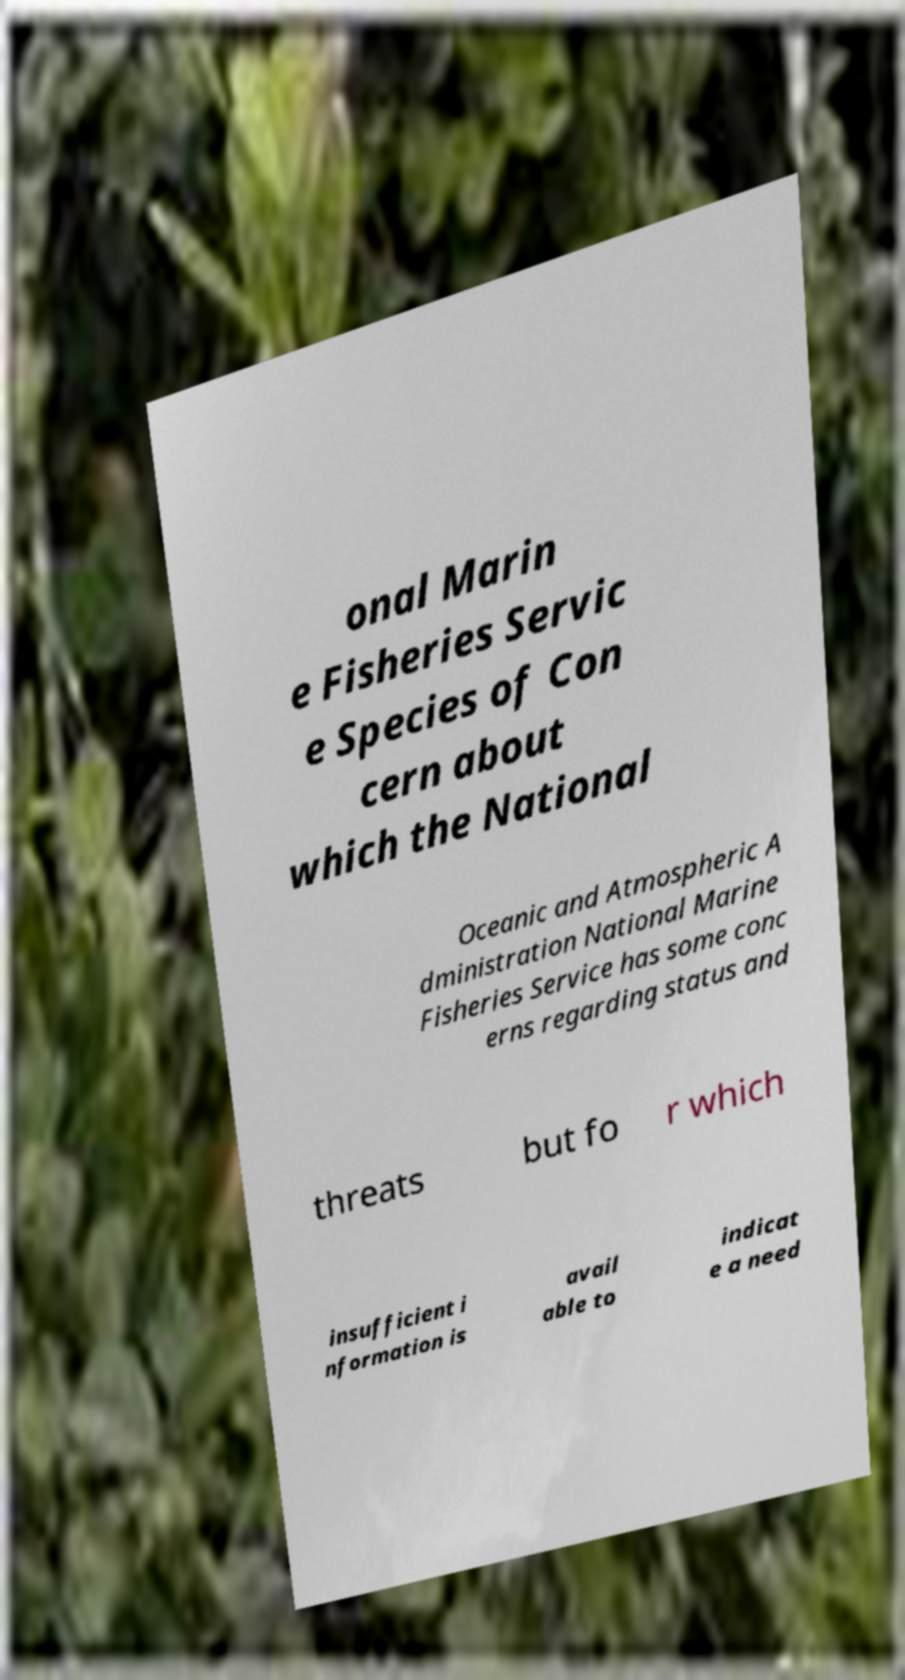I need the written content from this picture converted into text. Can you do that? onal Marin e Fisheries Servic e Species of Con cern about which the National Oceanic and Atmospheric A dministration National Marine Fisheries Service has some conc erns regarding status and threats but fo r which insufficient i nformation is avail able to indicat e a need 